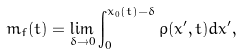<formula> <loc_0><loc_0><loc_500><loc_500>m _ { f } ( t ) = \lim _ { \delta \to 0 } \int _ { 0 } ^ { x _ { 0 } ( t ) - \delta } \rho ( x ^ { \prime } , t ) d x ^ { \prime } ,</formula> 